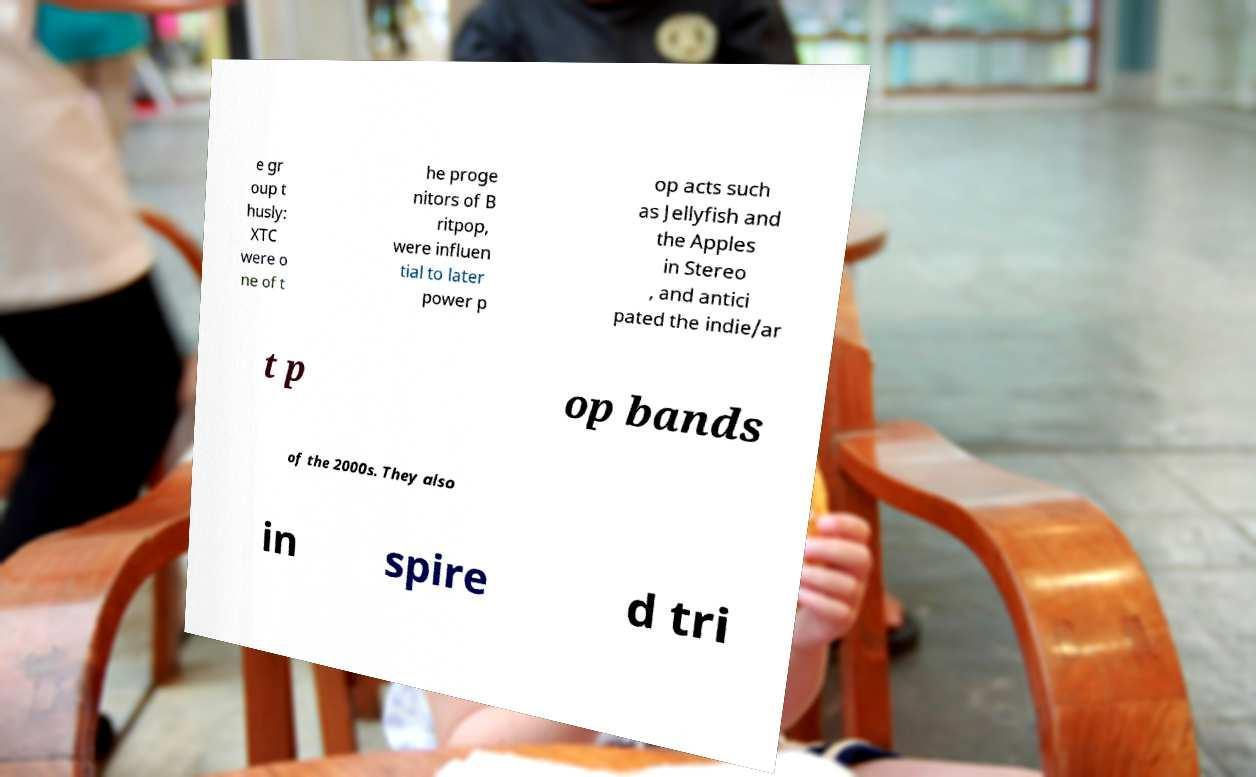Can you accurately transcribe the text from the provided image for me? e gr oup t husly: XTC were o ne of t he proge nitors of B ritpop, were influen tial to later power p op acts such as Jellyfish and the Apples in Stereo , and antici pated the indie/ar t p op bands of the 2000s. They also in spire d tri 